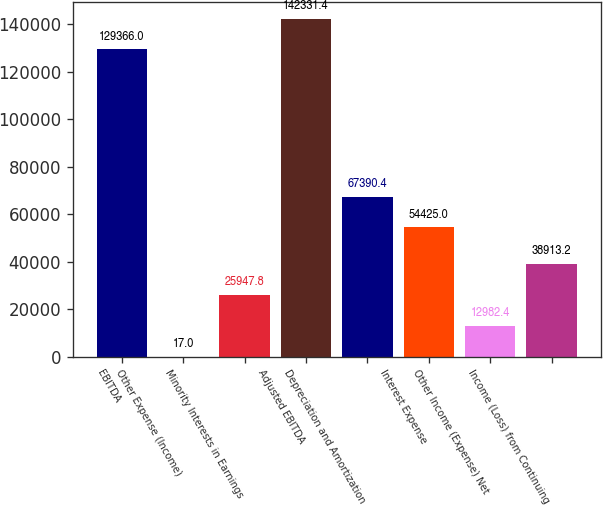Convert chart. <chart><loc_0><loc_0><loc_500><loc_500><bar_chart><fcel>EBITDA<fcel>Other Expense (Income)<fcel>Minority Interests in Earnings<fcel>Adjusted EBITDA<fcel>Depreciation and Amortization<fcel>Interest Expense<fcel>Other Income (Expense) Net<fcel>Income (Loss) from Continuing<nl><fcel>129366<fcel>17<fcel>25947.8<fcel>142331<fcel>67390.4<fcel>54425<fcel>12982.4<fcel>38913.2<nl></chart> 